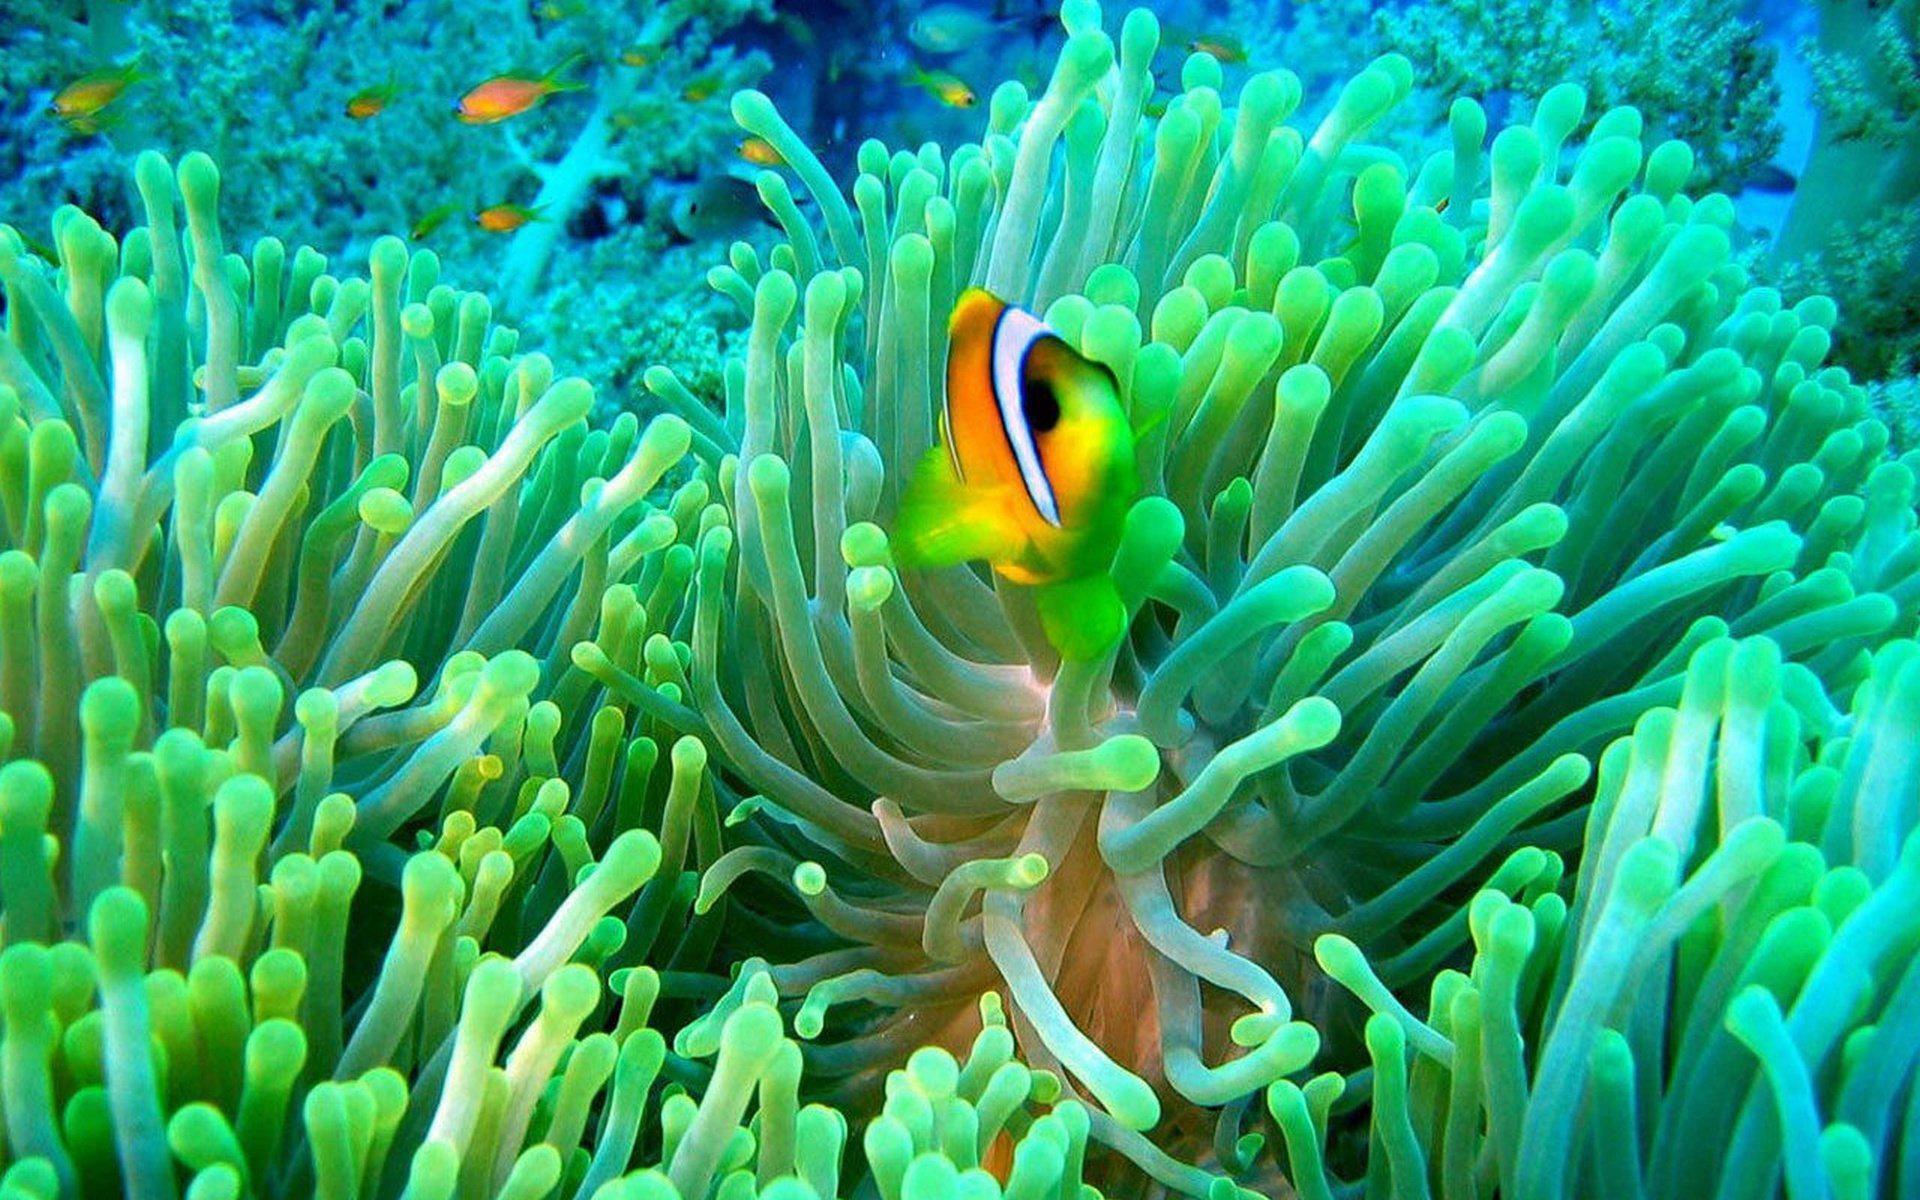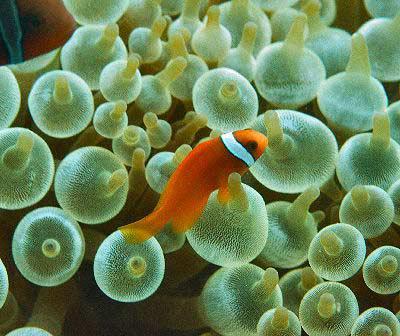The first image is the image on the left, the second image is the image on the right. For the images shown, is this caption "There are two or fewer fish across both images." true? Answer yes or no. No. The first image is the image on the left, the second image is the image on the right. For the images displayed, is the sentence "An image shows an orange fish swimming amid green anemone tendrils, and the image contains multiple fish." factually correct? Answer yes or no. Yes. 